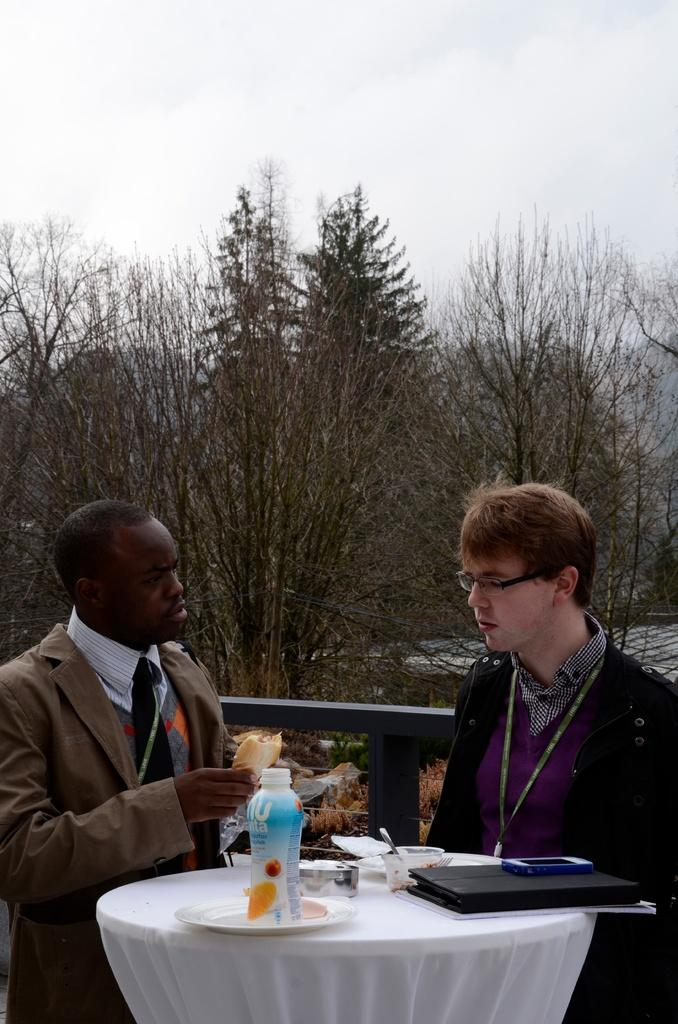How many people are in the image? There are two persons in the image. What are the two persons doing in the image? The two persons are standing. What object can be seen on the table in the image? There is a bottle and a file on the table. Can you see a window in the image? There is no window visible in the image. What type of key is being used to open the file in the image? There is no key present in the image, nor is there any indication that the file is being opened. 